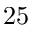<formula> <loc_0><loc_0><loc_500><loc_500>2 5</formula> 